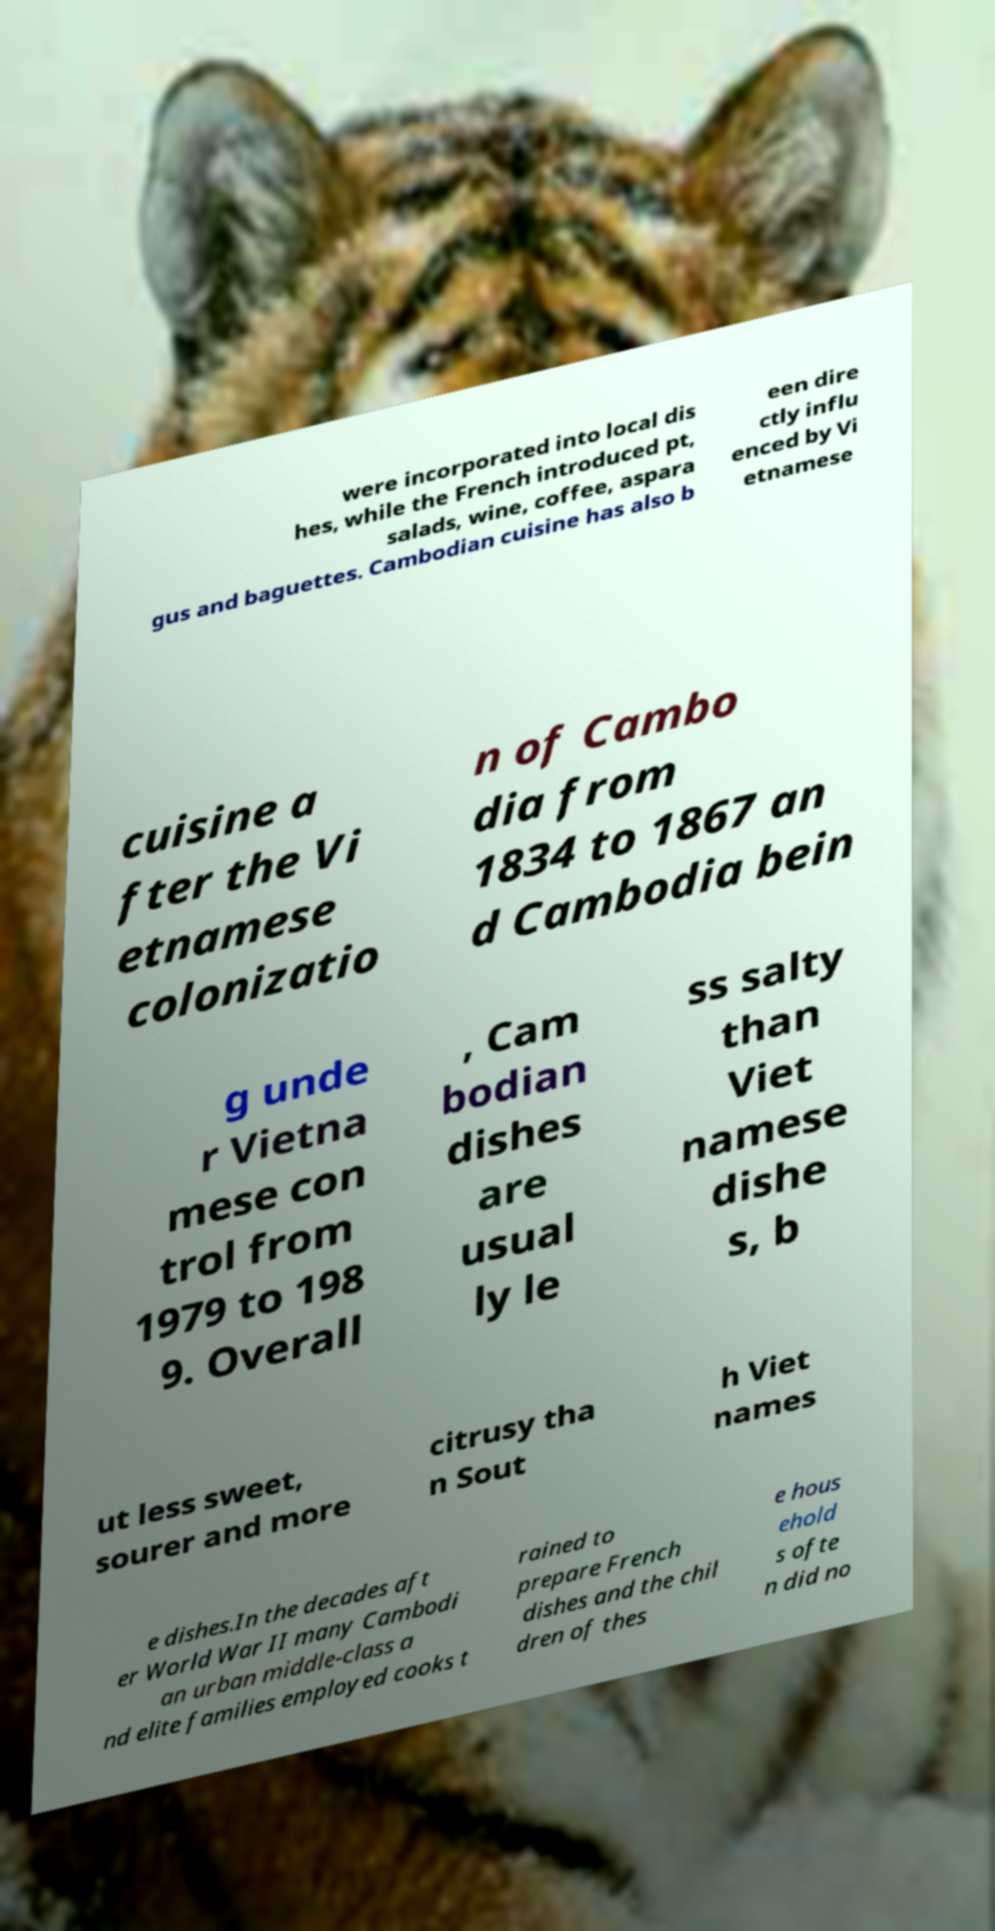There's text embedded in this image that I need extracted. Can you transcribe it verbatim? were incorporated into local dis hes, while the French introduced pt, salads, wine, coffee, aspara gus and baguettes. Cambodian cuisine has also b een dire ctly influ enced by Vi etnamese cuisine a fter the Vi etnamese colonizatio n of Cambo dia from 1834 to 1867 an d Cambodia bein g unde r Vietna mese con trol from 1979 to 198 9. Overall , Cam bodian dishes are usual ly le ss salty than Viet namese dishe s, b ut less sweet, sourer and more citrusy tha n Sout h Viet names e dishes.In the decades aft er World War II many Cambodi an urban middle-class a nd elite families employed cooks t rained to prepare French dishes and the chil dren of thes e hous ehold s ofte n did no 